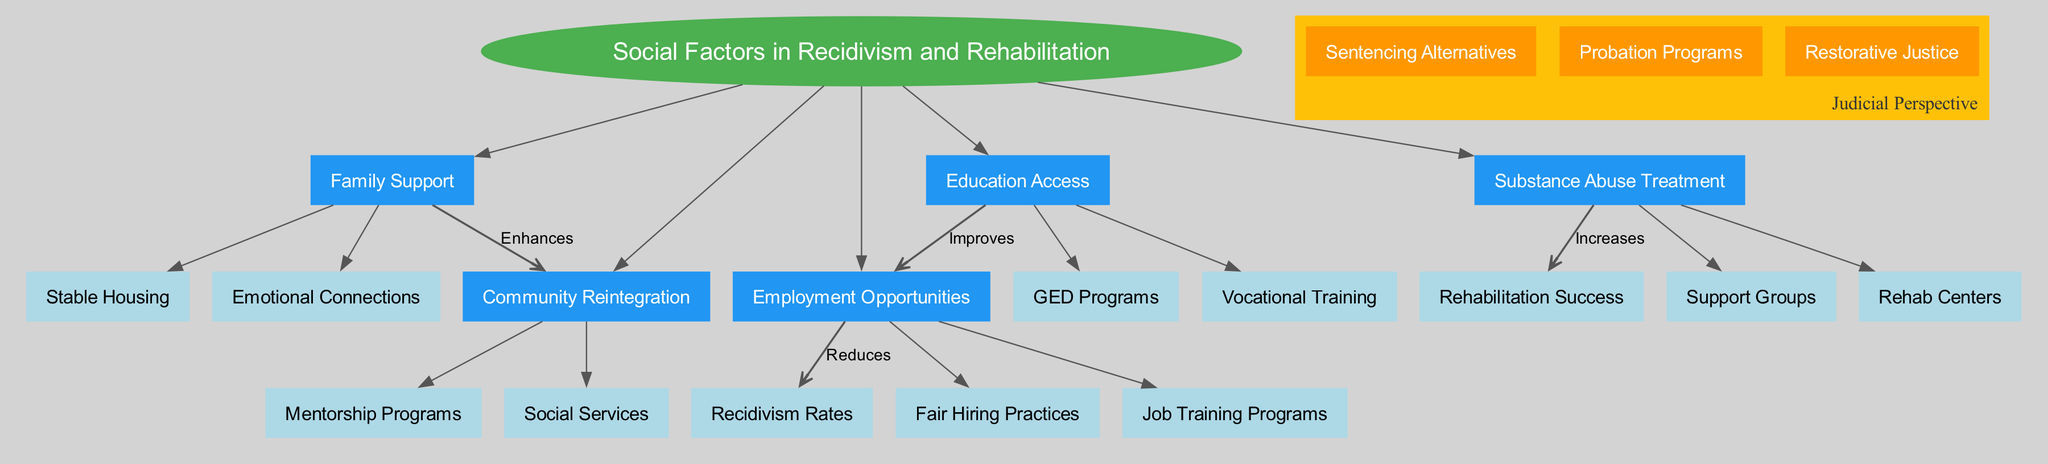What is the central topic of the diagram? The diagram's central topic is stated at the top and is clear and prominent. It is the overarching theme that connects all other nodes.
Answer: Social Factors in Recidivism and Rehabilitation How many main factors are depicted in the diagram? The main factors are listed branching from the central topic. By counting the number of distinct factors connected to the central node, we can identify the total.
Answer: 5 Which main factor enhances community reintegration? The directed edge from the stated main factor to the community reintegration shows that it plays a significant role in facilitating the process.
Answer: Family Support What does employment opportunities reduce? The diagram explicitly shows an arrow leading from employment opportunities to recidivism rates, indicating a direct impact where one influences the other.
Answer: Recidivism Rates How do education access and employment opportunities relate? The connection illustrated by the edge highlights an improvement pathway from education access to employment opportunities, showing how one factor supports the other.
Answer: Improves What increases rehabilitation success according to the diagram? The arrow points from substance abuse treatment to rehabilitation success, clearly indicating that this factor positively influences the latter.
Answer: Increases Which two sub-factors belong to community reintegration? The sub-factors pertaining to community reintegration are detailed within its cluster, allowing for direct identification through visual grouping.
Answer: Mentorship Programs, Social Services What role do job training programs play in reducing recidivism? The diagram shows that job training programs fall under employment opportunities, which in turn connects to the reduction of recidivism rates. They create pathways to stable employment, which is crucial for this effect.
Answer: Reduces What is one aspect of the judicial perspective noted in the diagram? The judicial perspective cluster includes nodes that denote approaches to justice that focus on alternatives, visible at the bottom of the diagram showing various strategies.
Answer: Sentencing Alternatives 